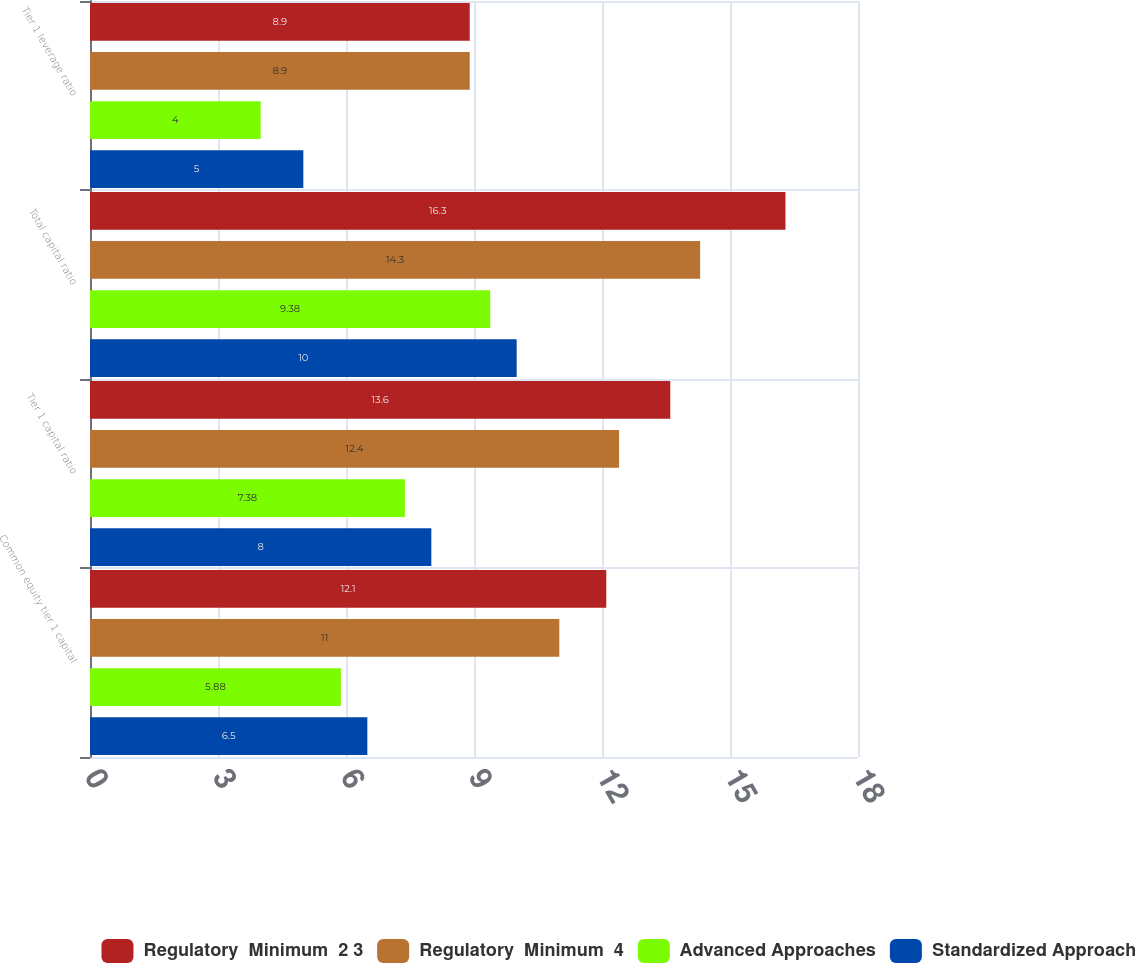<chart> <loc_0><loc_0><loc_500><loc_500><stacked_bar_chart><ecel><fcel>Common equity tier 1 capital<fcel>Tier 1 capital ratio<fcel>Total capital ratio<fcel>Tier 1 leverage ratio<nl><fcel>Regulatory  Minimum  2 3<fcel>12.1<fcel>13.6<fcel>16.3<fcel>8.9<nl><fcel>Regulatory  Minimum  4<fcel>11<fcel>12.4<fcel>14.3<fcel>8.9<nl><fcel>Advanced Approaches<fcel>5.88<fcel>7.38<fcel>9.38<fcel>4<nl><fcel>Standardized Approach<fcel>6.5<fcel>8<fcel>10<fcel>5<nl></chart> 